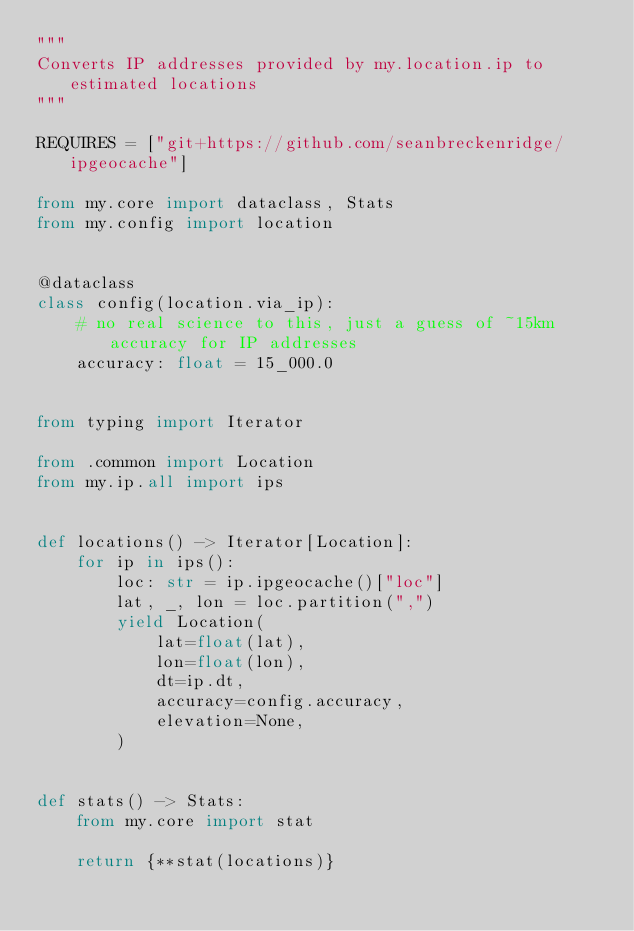Convert code to text. <code><loc_0><loc_0><loc_500><loc_500><_Python_>"""
Converts IP addresses provided by my.location.ip to estimated locations
"""

REQUIRES = ["git+https://github.com/seanbreckenridge/ipgeocache"]

from my.core import dataclass, Stats
from my.config import location


@dataclass
class config(location.via_ip):
    # no real science to this, just a guess of ~15km accuracy for IP addresses
    accuracy: float = 15_000.0


from typing import Iterator

from .common import Location
from my.ip.all import ips


def locations() -> Iterator[Location]:
    for ip in ips():
        loc: str = ip.ipgeocache()["loc"]
        lat, _, lon = loc.partition(",")
        yield Location(
            lat=float(lat),
            lon=float(lon),
            dt=ip.dt,
            accuracy=config.accuracy,
            elevation=None,
        )


def stats() -> Stats:
    from my.core import stat

    return {**stat(locations)}
</code> 